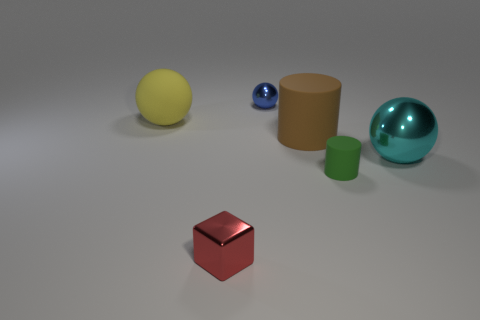Is the small ball made of the same material as the large sphere to the right of the large yellow matte sphere?
Offer a terse response. Yes. What number of tiny red shiny blocks are left of the metal thing to the right of the rubber cylinder that is in front of the cyan thing?
Offer a very short reply. 1. How many blue objects are small objects or matte things?
Your response must be concise. 1. What shape is the tiny object behind the green object?
Your response must be concise. Sphere. There is another rubber thing that is the same size as the yellow matte thing; what color is it?
Offer a terse response. Brown. There is a small red metallic thing; does it have the same shape as the metal thing that is behind the cyan object?
Your response must be concise. No. What is the ball that is right of the tiny shiny object on the right side of the small object that is left of the blue metal thing made of?
Your response must be concise. Metal. What number of small objects are cyan balls or red rubber cylinders?
Your answer should be compact. 0. How many other objects are the same size as the cyan metal thing?
Your answer should be very brief. 2. There is a tiny metallic object behind the red metal cube; is its shape the same as the large cyan metal object?
Your answer should be very brief. Yes. 